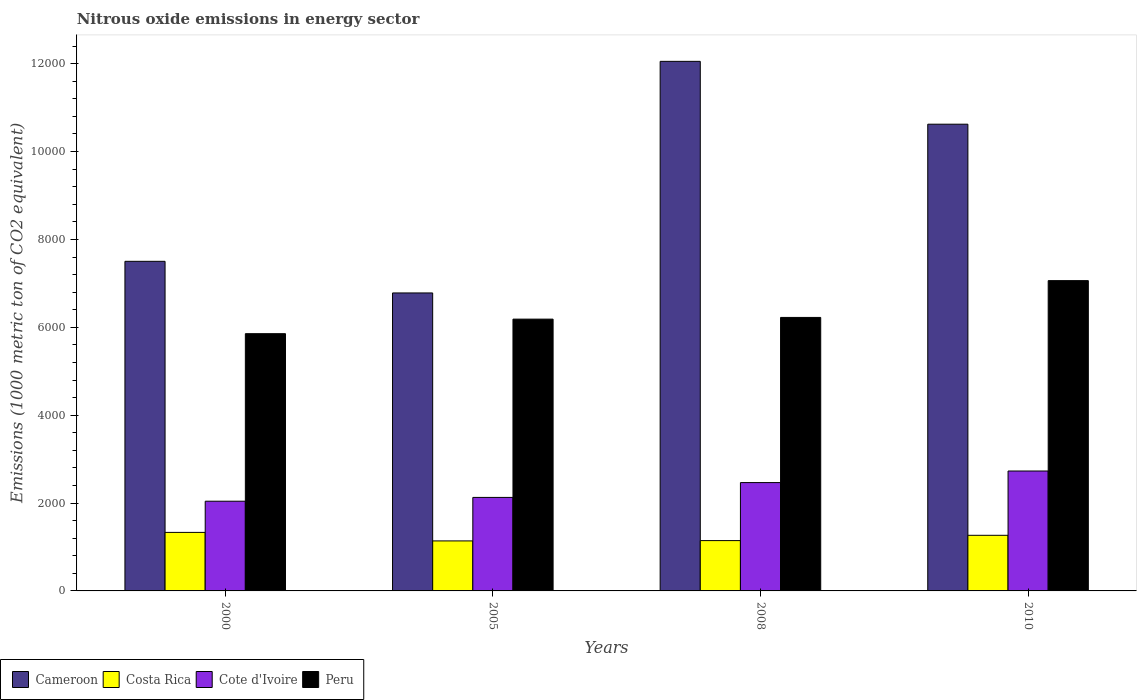How many different coloured bars are there?
Provide a succinct answer. 4. Are the number of bars per tick equal to the number of legend labels?
Ensure brevity in your answer.  Yes. Are the number of bars on each tick of the X-axis equal?
Make the answer very short. Yes. How many bars are there on the 3rd tick from the left?
Make the answer very short. 4. How many bars are there on the 3rd tick from the right?
Provide a succinct answer. 4. What is the label of the 2nd group of bars from the left?
Provide a succinct answer. 2005. In how many cases, is the number of bars for a given year not equal to the number of legend labels?
Your response must be concise. 0. What is the amount of nitrous oxide emitted in Costa Rica in 2005?
Your answer should be very brief. 1138.2. Across all years, what is the maximum amount of nitrous oxide emitted in Cameroon?
Provide a succinct answer. 1.21e+04. Across all years, what is the minimum amount of nitrous oxide emitted in Costa Rica?
Provide a short and direct response. 1138.2. In which year was the amount of nitrous oxide emitted in Cameroon maximum?
Your answer should be very brief. 2008. In which year was the amount of nitrous oxide emitted in Costa Rica minimum?
Your answer should be compact. 2005. What is the total amount of nitrous oxide emitted in Cameroon in the graph?
Your response must be concise. 3.70e+04. What is the difference between the amount of nitrous oxide emitted in Costa Rica in 2005 and that in 2010?
Keep it short and to the point. -127.5. What is the difference between the amount of nitrous oxide emitted in Cote d'Ivoire in 2010 and the amount of nitrous oxide emitted in Cameroon in 2005?
Offer a terse response. -4052.6. What is the average amount of nitrous oxide emitted in Cameroon per year?
Offer a terse response. 9239.75. In the year 2008, what is the difference between the amount of nitrous oxide emitted in Cote d'Ivoire and amount of nitrous oxide emitted in Cameroon?
Give a very brief answer. -9587.3. What is the ratio of the amount of nitrous oxide emitted in Costa Rica in 2008 to that in 2010?
Your response must be concise. 0.9. Is the amount of nitrous oxide emitted in Cote d'Ivoire in 2008 less than that in 2010?
Keep it short and to the point. Yes. Is the difference between the amount of nitrous oxide emitted in Cote d'Ivoire in 2008 and 2010 greater than the difference between the amount of nitrous oxide emitted in Cameroon in 2008 and 2010?
Your answer should be compact. No. What is the difference between the highest and the second highest amount of nitrous oxide emitted in Peru?
Offer a very short reply. 837.5. What is the difference between the highest and the lowest amount of nitrous oxide emitted in Cote d'Ivoire?
Provide a succinct answer. 687.5. Is it the case that in every year, the sum of the amount of nitrous oxide emitted in Cameroon and amount of nitrous oxide emitted in Cote d'Ivoire is greater than the sum of amount of nitrous oxide emitted in Costa Rica and amount of nitrous oxide emitted in Peru?
Your response must be concise. No. What does the 3rd bar from the right in 2005 represents?
Keep it short and to the point. Costa Rica. How many bars are there?
Ensure brevity in your answer.  16. Are all the bars in the graph horizontal?
Offer a terse response. No. What is the difference between two consecutive major ticks on the Y-axis?
Your answer should be very brief. 2000. Are the values on the major ticks of Y-axis written in scientific E-notation?
Provide a short and direct response. No. Does the graph contain any zero values?
Make the answer very short. No. Does the graph contain grids?
Your answer should be very brief. No. Where does the legend appear in the graph?
Make the answer very short. Bottom left. How are the legend labels stacked?
Offer a very short reply. Horizontal. What is the title of the graph?
Your answer should be very brief. Nitrous oxide emissions in energy sector. Does "Tuvalu" appear as one of the legend labels in the graph?
Your answer should be compact. No. What is the label or title of the X-axis?
Provide a succinct answer. Years. What is the label or title of the Y-axis?
Provide a short and direct response. Emissions (1000 metric ton of CO2 equivalent). What is the Emissions (1000 metric ton of CO2 equivalent) of Cameroon in 2000?
Ensure brevity in your answer.  7501.6. What is the Emissions (1000 metric ton of CO2 equivalent) in Costa Rica in 2000?
Provide a short and direct response. 1331.8. What is the Emissions (1000 metric ton of CO2 equivalent) of Cote d'Ivoire in 2000?
Provide a succinct answer. 2041.8. What is the Emissions (1000 metric ton of CO2 equivalent) in Peru in 2000?
Provide a short and direct response. 5854.9. What is the Emissions (1000 metric ton of CO2 equivalent) in Cameroon in 2005?
Give a very brief answer. 6781.9. What is the Emissions (1000 metric ton of CO2 equivalent) in Costa Rica in 2005?
Offer a very short reply. 1138.2. What is the Emissions (1000 metric ton of CO2 equivalent) in Cote d'Ivoire in 2005?
Offer a terse response. 2128.3. What is the Emissions (1000 metric ton of CO2 equivalent) of Peru in 2005?
Your response must be concise. 6185.8. What is the Emissions (1000 metric ton of CO2 equivalent) of Cameroon in 2008?
Offer a very short reply. 1.21e+04. What is the Emissions (1000 metric ton of CO2 equivalent) in Costa Rica in 2008?
Provide a succinct answer. 1145.2. What is the Emissions (1000 metric ton of CO2 equivalent) of Cote d'Ivoire in 2008?
Give a very brief answer. 2465.6. What is the Emissions (1000 metric ton of CO2 equivalent) of Peru in 2008?
Your response must be concise. 6224.5. What is the Emissions (1000 metric ton of CO2 equivalent) of Cameroon in 2010?
Make the answer very short. 1.06e+04. What is the Emissions (1000 metric ton of CO2 equivalent) in Costa Rica in 2010?
Your response must be concise. 1265.7. What is the Emissions (1000 metric ton of CO2 equivalent) of Cote d'Ivoire in 2010?
Give a very brief answer. 2729.3. What is the Emissions (1000 metric ton of CO2 equivalent) of Peru in 2010?
Make the answer very short. 7062. Across all years, what is the maximum Emissions (1000 metric ton of CO2 equivalent) in Cameroon?
Offer a terse response. 1.21e+04. Across all years, what is the maximum Emissions (1000 metric ton of CO2 equivalent) in Costa Rica?
Offer a very short reply. 1331.8. Across all years, what is the maximum Emissions (1000 metric ton of CO2 equivalent) in Cote d'Ivoire?
Provide a succinct answer. 2729.3. Across all years, what is the maximum Emissions (1000 metric ton of CO2 equivalent) in Peru?
Your response must be concise. 7062. Across all years, what is the minimum Emissions (1000 metric ton of CO2 equivalent) of Cameroon?
Provide a short and direct response. 6781.9. Across all years, what is the minimum Emissions (1000 metric ton of CO2 equivalent) of Costa Rica?
Your answer should be very brief. 1138.2. Across all years, what is the minimum Emissions (1000 metric ton of CO2 equivalent) of Cote d'Ivoire?
Your answer should be compact. 2041.8. Across all years, what is the minimum Emissions (1000 metric ton of CO2 equivalent) in Peru?
Give a very brief answer. 5854.9. What is the total Emissions (1000 metric ton of CO2 equivalent) in Cameroon in the graph?
Make the answer very short. 3.70e+04. What is the total Emissions (1000 metric ton of CO2 equivalent) of Costa Rica in the graph?
Your answer should be very brief. 4880.9. What is the total Emissions (1000 metric ton of CO2 equivalent) in Cote d'Ivoire in the graph?
Your response must be concise. 9365. What is the total Emissions (1000 metric ton of CO2 equivalent) in Peru in the graph?
Your answer should be compact. 2.53e+04. What is the difference between the Emissions (1000 metric ton of CO2 equivalent) in Cameroon in 2000 and that in 2005?
Ensure brevity in your answer.  719.7. What is the difference between the Emissions (1000 metric ton of CO2 equivalent) of Costa Rica in 2000 and that in 2005?
Your answer should be compact. 193.6. What is the difference between the Emissions (1000 metric ton of CO2 equivalent) in Cote d'Ivoire in 2000 and that in 2005?
Ensure brevity in your answer.  -86.5. What is the difference between the Emissions (1000 metric ton of CO2 equivalent) of Peru in 2000 and that in 2005?
Offer a terse response. -330.9. What is the difference between the Emissions (1000 metric ton of CO2 equivalent) in Cameroon in 2000 and that in 2008?
Provide a succinct answer. -4551.3. What is the difference between the Emissions (1000 metric ton of CO2 equivalent) in Costa Rica in 2000 and that in 2008?
Provide a short and direct response. 186.6. What is the difference between the Emissions (1000 metric ton of CO2 equivalent) in Cote d'Ivoire in 2000 and that in 2008?
Give a very brief answer. -423.8. What is the difference between the Emissions (1000 metric ton of CO2 equivalent) of Peru in 2000 and that in 2008?
Your answer should be very brief. -369.6. What is the difference between the Emissions (1000 metric ton of CO2 equivalent) of Cameroon in 2000 and that in 2010?
Offer a very short reply. -3121. What is the difference between the Emissions (1000 metric ton of CO2 equivalent) of Costa Rica in 2000 and that in 2010?
Provide a short and direct response. 66.1. What is the difference between the Emissions (1000 metric ton of CO2 equivalent) in Cote d'Ivoire in 2000 and that in 2010?
Keep it short and to the point. -687.5. What is the difference between the Emissions (1000 metric ton of CO2 equivalent) in Peru in 2000 and that in 2010?
Give a very brief answer. -1207.1. What is the difference between the Emissions (1000 metric ton of CO2 equivalent) of Cameroon in 2005 and that in 2008?
Ensure brevity in your answer.  -5271. What is the difference between the Emissions (1000 metric ton of CO2 equivalent) of Costa Rica in 2005 and that in 2008?
Make the answer very short. -7. What is the difference between the Emissions (1000 metric ton of CO2 equivalent) of Cote d'Ivoire in 2005 and that in 2008?
Keep it short and to the point. -337.3. What is the difference between the Emissions (1000 metric ton of CO2 equivalent) in Peru in 2005 and that in 2008?
Ensure brevity in your answer.  -38.7. What is the difference between the Emissions (1000 metric ton of CO2 equivalent) in Cameroon in 2005 and that in 2010?
Give a very brief answer. -3840.7. What is the difference between the Emissions (1000 metric ton of CO2 equivalent) of Costa Rica in 2005 and that in 2010?
Offer a terse response. -127.5. What is the difference between the Emissions (1000 metric ton of CO2 equivalent) of Cote d'Ivoire in 2005 and that in 2010?
Keep it short and to the point. -601. What is the difference between the Emissions (1000 metric ton of CO2 equivalent) of Peru in 2005 and that in 2010?
Ensure brevity in your answer.  -876.2. What is the difference between the Emissions (1000 metric ton of CO2 equivalent) in Cameroon in 2008 and that in 2010?
Keep it short and to the point. 1430.3. What is the difference between the Emissions (1000 metric ton of CO2 equivalent) of Costa Rica in 2008 and that in 2010?
Give a very brief answer. -120.5. What is the difference between the Emissions (1000 metric ton of CO2 equivalent) of Cote d'Ivoire in 2008 and that in 2010?
Offer a terse response. -263.7. What is the difference between the Emissions (1000 metric ton of CO2 equivalent) of Peru in 2008 and that in 2010?
Ensure brevity in your answer.  -837.5. What is the difference between the Emissions (1000 metric ton of CO2 equivalent) of Cameroon in 2000 and the Emissions (1000 metric ton of CO2 equivalent) of Costa Rica in 2005?
Provide a short and direct response. 6363.4. What is the difference between the Emissions (1000 metric ton of CO2 equivalent) of Cameroon in 2000 and the Emissions (1000 metric ton of CO2 equivalent) of Cote d'Ivoire in 2005?
Provide a succinct answer. 5373.3. What is the difference between the Emissions (1000 metric ton of CO2 equivalent) of Cameroon in 2000 and the Emissions (1000 metric ton of CO2 equivalent) of Peru in 2005?
Provide a succinct answer. 1315.8. What is the difference between the Emissions (1000 metric ton of CO2 equivalent) in Costa Rica in 2000 and the Emissions (1000 metric ton of CO2 equivalent) in Cote d'Ivoire in 2005?
Your response must be concise. -796.5. What is the difference between the Emissions (1000 metric ton of CO2 equivalent) of Costa Rica in 2000 and the Emissions (1000 metric ton of CO2 equivalent) of Peru in 2005?
Provide a short and direct response. -4854. What is the difference between the Emissions (1000 metric ton of CO2 equivalent) in Cote d'Ivoire in 2000 and the Emissions (1000 metric ton of CO2 equivalent) in Peru in 2005?
Give a very brief answer. -4144. What is the difference between the Emissions (1000 metric ton of CO2 equivalent) of Cameroon in 2000 and the Emissions (1000 metric ton of CO2 equivalent) of Costa Rica in 2008?
Keep it short and to the point. 6356.4. What is the difference between the Emissions (1000 metric ton of CO2 equivalent) in Cameroon in 2000 and the Emissions (1000 metric ton of CO2 equivalent) in Cote d'Ivoire in 2008?
Your response must be concise. 5036. What is the difference between the Emissions (1000 metric ton of CO2 equivalent) in Cameroon in 2000 and the Emissions (1000 metric ton of CO2 equivalent) in Peru in 2008?
Your answer should be very brief. 1277.1. What is the difference between the Emissions (1000 metric ton of CO2 equivalent) in Costa Rica in 2000 and the Emissions (1000 metric ton of CO2 equivalent) in Cote d'Ivoire in 2008?
Keep it short and to the point. -1133.8. What is the difference between the Emissions (1000 metric ton of CO2 equivalent) of Costa Rica in 2000 and the Emissions (1000 metric ton of CO2 equivalent) of Peru in 2008?
Your response must be concise. -4892.7. What is the difference between the Emissions (1000 metric ton of CO2 equivalent) in Cote d'Ivoire in 2000 and the Emissions (1000 metric ton of CO2 equivalent) in Peru in 2008?
Your answer should be very brief. -4182.7. What is the difference between the Emissions (1000 metric ton of CO2 equivalent) in Cameroon in 2000 and the Emissions (1000 metric ton of CO2 equivalent) in Costa Rica in 2010?
Your response must be concise. 6235.9. What is the difference between the Emissions (1000 metric ton of CO2 equivalent) of Cameroon in 2000 and the Emissions (1000 metric ton of CO2 equivalent) of Cote d'Ivoire in 2010?
Offer a very short reply. 4772.3. What is the difference between the Emissions (1000 metric ton of CO2 equivalent) in Cameroon in 2000 and the Emissions (1000 metric ton of CO2 equivalent) in Peru in 2010?
Give a very brief answer. 439.6. What is the difference between the Emissions (1000 metric ton of CO2 equivalent) in Costa Rica in 2000 and the Emissions (1000 metric ton of CO2 equivalent) in Cote d'Ivoire in 2010?
Keep it short and to the point. -1397.5. What is the difference between the Emissions (1000 metric ton of CO2 equivalent) of Costa Rica in 2000 and the Emissions (1000 metric ton of CO2 equivalent) of Peru in 2010?
Make the answer very short. -5730.2. What is the difference between the Emissions (1000 metric ton of CO2 equivalent) of Cote d'Ivoire in 2000 and the Emissions (1000 metric ton of CO2 equivalent) of Peru in 2010?
Your answer should be compact. -5020.2. What is the difference between the Emissions (1000 metric ton of CO2 equivalent) in Cameroon in 2005 and the Emissions (1000 metric ton of CO2 equivalent) in Costa Rica in 2008?
Your answer should be very brief. 5636.7. What is the difference between the Emissions (1000 metric ton of CO2 equivalent) of Cameroon in 2005 and the Emissions (1000 metric ton of CO2 equivalent) of Cote d'Ivoire in 2008?
Your response must be concise. 4316.3. What is the difference between the Emissions (1000 metric ton of CO2 equivalent) in Cameroon in 2005 and the Emissions (1000 metric ton of CO2 equivalent) in Peru in 2008?
Provide a succinct answer. 557.4. What is the difference between the Emissions (1000 metric ton of CO2 equivalent) in Costa Rica in 2005 and the Emissions (1000 metric ton of CO2 equivalent) in Cote d'Ivoire in 2008?
Keep it short and to the point. -1327.4. What is the difference between the Emissions (1000 metric ton of CO2 equivalent) of Costa Rica in 2005 and the Emissions (1000 metric ton of CO2 equivalent) of Peru in 2008?
Keep it short and to the point. -5086.3. What is the difference between the Emissions (1000 metric ton of CO2 equivalent) of Cote d'Ivoire in 2005 and the Emissions (1000 metric ton of CO2 equivalent) of Peru in 2008?
Ensure brevity in your answer.  -4096.2. What is the difference between the Emissions (1000 metric ton of CO2 equivalent) in Cameroon in 2005 and the Emissions (1000 metric ton of CO2 equivalent) in Costa Rica in 2010?
Offer a terse response. 5516.2. What is the difference between the Emissions (1000 metric ton of CO2 equivalent) in Cameroon in 2005 and the Emissions (1000 metric ton of CO2 equivalent) in Cote d'Ivoire in 2010?
Ensure brevity in your answer.  4052.6. What is the difference between the Emissions (1000 metric ton of CO2 equivalent) of Cameroon in 2005 and the Emissions (1000 metric ton of CO2 equivalent) of Peru in 2010?
Give a very brief answer. -280.1. What is the difference between the Emissions (1000 metric ton of CO2 equivalent) in Costa Rica in 2005 and the Emissions (1000 metric ton of CO2 equivalent) in Cote d'Ivoire in 2010?
Provide a short and direct response. -1591.1. What is the difference between the Emissions (1000 metric ton of CO2 equivalent) of Costa Rica in 2005 and the Emissions (1000 metric ton of CO2 equivalent) of Peru in 2010?
Ensure brevity in your answer.  -5923.8. What is the difference between the Emissions (1000 metric ton of CO2 equivalent) of Cote d'Ivoire in 2005 and the Emissions (1000 metric ton of CO2 equivalent) of Peru in 2010?
Keep it short and to the point. -4933.7. What is the difference between the Emissions (1000 metric ton of CO2 equivalent) of Cameroon in 2008 and the Emissions (1000 metric ton of CO2 equivalent) of Costa Rica in 2010?
Ensure brevity in your answer.  1.08e+04. What is the difference between the Emissions (1000 metric ton of CO2 equivalent) in Cameroon in 2008 and the Emissions (1000 metric ton of CO2 equivalent) in Cote d'Ivoire in 2010?
Your response must be concise. 9323.6. What is the difference between the Emissions (1000 metric ton of CO2 equivalent) in Cameroon in 2008 and the Emissions (1000 metric ton of CO2 equivalent) in Peru in 2010?
Provide a short and direct response. 4990.9. What is the difference between the Emissions (1000 metric ton of CO2 equivalent) of Costa Rica in 2008 and the Emissions (1000 metric ton of CO2 equivalent) of Cote d'Ivoire in 2010?
Your response must be concise. -1584.1. What is the difference between the Emissions (1000 metric ton of CO2 equivalent) in Costa Rica in 2008 and the Emissions (1000 metric ton of CO2 equivalent) in Peru in 2010?
Make the answer very short. -5916.8. What is the difference between the Emissions (1000 metric ton of CO2 equivalent) in Cote d'Ivoire in 2008 and the Emissions (1000 metric ton of CO2 equivalent) in Peru in 2010?
Offer a very short reply. -4596.4. What is the average Emissions (1000 metric ton of CO2 equivalent) of Cameroon per year?
Provide a succinct answer. 9239.75. What is the average Emissions (1000 metric ton of CO2 equivalent) in Costa Rica per year?
Give a very brief answer. 1220.22. What is the average Emissions (1000 metric ton of CO2 equivalent) in Cote d'Ivoire per year?
Offer a terse response. 2341.25. What is the average Emissions (1000 metric ton of CO2 equivalent) of Peru per year?
Provide a succinct answer. 6331.8. In the year 2000, what is the difference between the Emissions (1000 metric ton of CO2 equivalent) of Cameroon and Emissions (1000 metric ton of CO2 equivalent) of Costa Rica?
Provide a succinct answer. 6169.8. In the year 2000, what is the difference between the Emissions (1000 metric ton of CO2 equivalent) in Cameroon and Emissions (1000 metric ton of CO2 equivalent) in Cote d'Ivoire?
Your response must be concise. 5459.8. In the year 2000, what is the difference between the Emissions (1000 metric ton of CO2 equivalent) of Cameroon and Emissions (1000 metric ton of CO2 equivalent) of Peru?
Your response must be concise. 1646.7. In the year 2000, what is the difference between the Emissions (1000 metric ton of CO2 equivalent) in Costa Rica and Emissions (1000 metric ton of CO2 equivalent) in Cote d'Ivoire?
Make the answer very short. -710. In the year 2000, what is the difference between the Emissions (1000 metric ton of CO2 equivalent) in Costa Rica and Emissions (1000 metric ton of CO2 equivalent) in Peru?
Your response must be concise. -4523.1. In the year 2000, what is the difference between the Emissions (1000 metric ton of CO2 equivalent) of Cote d'Ivoire and Emissions (1000 metric ton of CO2 equivalent) of Peru?
Your answer should be compact. -3813.1. In the year 2005, what is the difference between the Emissions (1000 metric ton of CO2 equivalent) of Cameroon and Emissions (1000 metric ton of CO2 equivalent) of Costa Rica?
Your response must be concise. 5643.7. In the year 2005, what is the difference between the Emissions (1000 metric ton of CO2 equivalent) in Cameroon and Emissions (1000 metric ton of CO2 equivalent) in Cote d'Ivoire?
Give a very brief answer. 4653.6. In the year 2005, what is the difference between the Emissions (1000 metric ton of CO2 equivalent) of Cameroon and Emissions (1000 metric ton of CO2 equivalent) of Peru?
Your answer should be very brief. 596.1. In the year 2005, what is the difference between the Emissions (1000 metric ton of CO2 equivalent) in Costa Rica and Emissions (1000 metric ton of CO2 equivalent) in Cote d'Ivoire?
Make the answer very short. -990.1. In the year 2005, what is the difference between the Emissions (1000 metric ton of CO2 equivalent) in Costa Rica and Emissions (1000 metric ton of CO2 equivalent) in Peru?
Your answer should be compact. -5047.6. In the year 2005, what is the difference between the Emissions (1000 metric ton of CO2 equivalent) in Cote d'Ivoire and Emissions (1000 metric ton of CO2 equivalent) in Peru?
Keep it short and to the point. -4057.5. In the year 2008, what is the difference between the Emissions (1000 metric ton of CO2 equivalent) in Cameroon and Emissions (1000 metric ton of CO2 equivalent) in Costa Rica?
Give a very brief answer. 1.09e+04. In the year 2008, what is the difference between the Emissions (1000 metric ton of CO2 equivalent) of Cameroon and Emissions (1000 metric ton of CO2 equivalent) of Cote d'Ivoire?
Provide a short and direct response. 9587.3. In the year 2008, what is the difference between the Emissions (1000 metric ton of CO2 equivalent) in Cameroon and Emissions (1000 metric ton of CO2 equivalent) in Peru?
Your response must be concise. 5828.4. In the year 2008, what is the difference between the Emissions (1000 metric ton of CO2 equivalent) in Costa Rica and Emissions (1000 metric ton of CO2 equivalent) in Cote d'Ivoire?
Your answer should be very brief. -1320.4. In the year 2008, what is the difference between the Emissions (1000 metric ton of CO2 equivalent) in Costa Rica and Emissions (1000 metric ton of CO2 equivalent) in Peru?
Your answer should be very brief. -5079.3. In the year 2008, what is the difference between the Emissions (1000 metric ton of CO2 equivalent) in Cote d'Ivoire and Emissions (1000 metric ton of CO2 equivalent) in Peru?
Keep it short and to the point. -3758.9. In the year 2010, what is the difference between the Emissions (1000 metric ton of CO2 equivalent) in Cameroon and Emissions (1000 metric ton of CO2 equivalent) in Costa Rica?
Keep it short and to the point. 9356.9. In the year 2010, what is the difference between the Emissions (1000 metric ton of CO2 equivalent) of Cameroon and Emissions (1000 metric ton of CO2 equivalent) of Cote d'Ivoire?
Offer a terse response. 7893.3. In the year 2010, what is the difference between the Emissions (1000 metric ton of CO2 equivalent) of Cameroon and Emissions (1000 metric ton of CO2 equivalent) of Peru?
Your response must be concise. 3560.6. In the year 2010, what is the difference between the Emissions (1000 metric ton of CO2 equivalent) in Costa Rica and Emissions (1000 metric ton of CO2 equivalent) in Cote d'Ivoire?
Give a very brief answer. -1463.6. In the year 2010, what is the difference between the Emissions (1000 metric ton of CO2 equivalent) of Costa Rica and Emissions (1000 metric ton of CO2 equivalent) of Peru?
Ensure brevity in your answer.  -5796.3. In the year 2010, what is the difference between the Emissions (1000 metric ton of CO2 equivalent) in Cote d'Ivoire and Emissions (1000 metric ton of CO2 equivalent) in Peru?
Keep it short and to the point. -4332.7. What is the ratio of the Emissions (1000 metric ton of CO2 equivalent) in Cameroon in 2000 to that in 2005?
Your answer should be very brief. 1.11. What is the ratio of the Emissions (1000 metric ton of CO2 equivalent) in Costa Rica in 2000 to that in 2005?
Your answer should be very brief. 1.17. What is the ratio of the Emissions (1000 metric ton of CO2 equivalent) in Cote d'Ivoire in 2000 to that in 2005?
Your response must be concise. 0.96. What is the ratio of the Emissions (1000 metric ton of CO2 equivalent) of Peru in 2000 to that in 2005?
Give a very brief answer. 0.95. What is the ratio of the Emissions (1000 metric ton of CO2 equivalent) in Cameroon in 2000 to that in 2008?
Offer a terse response. 0.62. What is the ratio of the Emissions (1000 metric ton of CO2 equivalent) of Costa Rica in 2000 to that in 2008?
Your response must be concise. 1.16. What is the ratio of the Emissions (1000 metric ton of CO2 equivalent) in Cote d'Ivoire in 2000 to that in 2008?
Offer a very short reply. 0.83. What is the ratio of the Emissions (1000 metric ton of CO2 equivalent) in Peru in 2000 to that in 2008?
Make the answer very short. 0.94. What is the ratio of the Emissions (1000 metric ton of CO2 equivalent) of Cameroon in 2000 to that in 2010?
Ensure brevity in your answer.  0.71. What is the ratio of the Emissions (1000 metric ton of CO2 equivalent) in Costa Rica in 2000 to that in 2010?
Your response must be concise. 1.05. What is the ratio of the Emissions (1000 metric ton of CO2 equivalent) in Cote d'Ivoire in 2000 to that in 2010?
Provide a succinct answer. 0.75. What is the ratio of the Emissions (1000 metric ton of CO2 equivalent) in Peru in 2000 to that in 2010?
Ensure brevity in your answer.  0.83. What is the ratio of the Emissions (1000 metric ton of CO2 equivalent) in Cameroon in 2005 to that in 2008?
Provide a short and direct response. 0.56. What is the ratio of the Emissions (1000 metric ton of CO2 equivalent) in Cote d'Ivoire in 2005 to that in 2008?
Provide a short and direct response. 0.86. What is the ratio of the Emissions (1000 metric ton of CO2 equivalent) in Cameroon in 2005 to that in 2010?
Keep it short and to the point. 0.64. What is the ratio of the Emissions (1000 metric ton of CO2 equivalent) of Costa Rica in 2005 to that in 2010?
Your answer should be compact. 0.9. What is the ratio of the Emissions (1000 metric ton of CO2 equivalent) of Cote d'Ivoire in 2005 to that in 2010?
Your response must be concise. 0.78. What is the ratio of the Emissions (1000 metric ton of CO2 equivalent) in Peru in 2005 to that in 2010?
Make the answer very short. 0.88. What is the ratio of the Emissions (1000 metric ton of CO2 equivalent) of Cameroon in 2008 to that in 2010?
Make the answer very short. 1.13. What is the ratio of the Emissions (1000 metric ton of CO2 equivalent) of Costa Rica in 2008 to that in 2010?
Offer a terse response. 0.9. What is the ratio of the Emissions (1000 metric ton of CO2 equivalent) in Cote d'Ivoire in 2008 to that in 2010?
Provide a succinct answer. 0.9. What is the ratio of the Emissions (1000 metric ton of CO2 equivalent) of Peru in 2008 to that in 2010?
Your answer should be very brief. 0.88. What is the difference between the highest and the second highest Emissions (1000 metric ton of CO2 equivalent) in Cameroon?
Provide a short and direct response. 1430.3. What is the difference between the highest and the second highest Emissions (1000 metric ton of CO2 equivalent) of Costa Rica?
Your answer should be very brief. 66.1. What is the difference between the highest and the second highest Emissions (1000 metric ton of CO2 equivalent) of Cote d'Ivoire?
Provide a short and direct response. 263.7. What is the difference between the highest and the second highest Emissions (1000 metric ton of CO2 equivalent) in Peru?
Ensure brevity in your answer.  837.5. What is the difference between the highest and the lowest Emissions (1000 metric ton of CO2 equivalent) of Cameroon?
Ensure brevity in your answer.  5271. What is the difference between the highest and the lowest Emissions (1000 metric ton of CO2 equivalent) of Costa Rica?
Provide a short and direct response. 193.6. What is the difference between the highest and the lowest Emissions (1000 metric ton of CO2 equivalent) of Cote d'Ivoire?
Your answer should be compact. 687.5. What is the difference between the highest and the lowest Emissions (1000 metric ton of CO2 equivalent) in Peru?
Keep it short and to the point. 1207.1. 